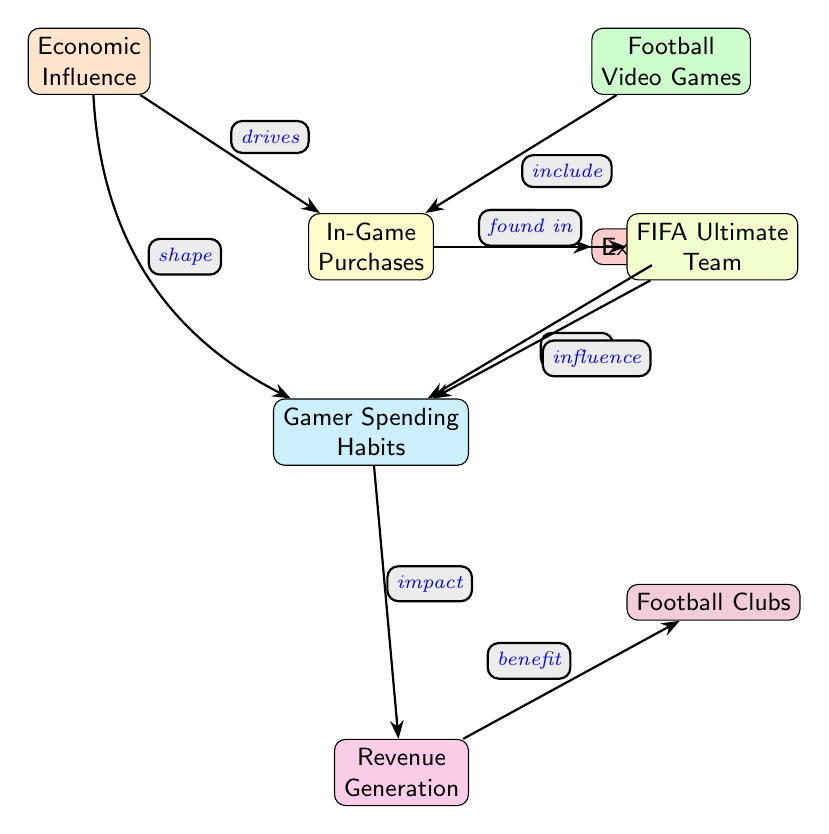What is the top node in the diagram? The top node in the diagram represents the main concept of the diagram, which is "Economic Influence."
Answer: Economic Influence How many nodes are present in the diagram? By counting each of the distinct rectangular boxes in the diagram, we find there are a total of eight nodes.
Answer: 8 What type of items are offered as a result of in-game purchases? The edge connecting the node "In-Game Purchases" to "Exclusive Items" indicates that in-game purchases lead to exclusive items.
Answer: Exclusive Items Which gaming mode is found in connection with in-game purchases? The edge labeled "found in" connects "In-Game Purchases" to "FIFA Ultimate Team," indicating that this mode includes those purchases.
Answer: FIFA Ultimate Team How do in-game purchases affect gamer spending habits? The edge labeled "affect" between "Exclusive Items" and "Gamer Spending Habits" shows that exclusive items have an influence on how gamers spend their money.
Answer: affect What impacts revenue generation according to the diagram? The edge labeled "impact" shows that "Gamer Spending Habits" have a direct impact on "Revenue Generation."
Answer: impact Which two nodes are connected by the relationship "drives"? The edge labeled "drives" connects "Economic Influence" and "In-Game Purchases," indicating that economic factors drive in-game purchases.
Answer: Economic Influence, In-Game Purchases What benefits football clubs? According to the diagram, "Revenue Generation," which is influenced by gamer spending habits, ultimately benefits football clubs.
Answer: benefit What is the relationship between "FIFA Ultimate Team" and "Gamer Spending Habits"? The edge labeled "influence" shows that "FIFA Ultimate Team" significantly influences "Gamer Spending Habits."
Answer: influence 